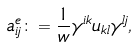Convert formula to latex. <formula><loc_0><loc_0><loc_500><loc_500>a ^ { e } _ { i j } \colon = \frac { 1 } { w } \gamma ^ { i k } u _ { k l } \gamma ^ { l j } ,</formula> 